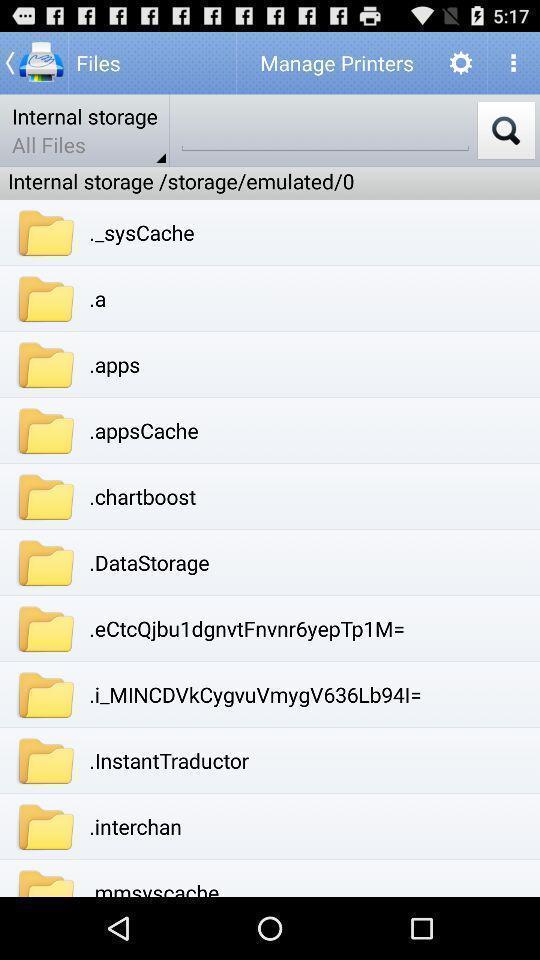Summarize the main components in this picture. Screen shows about internal storage. 